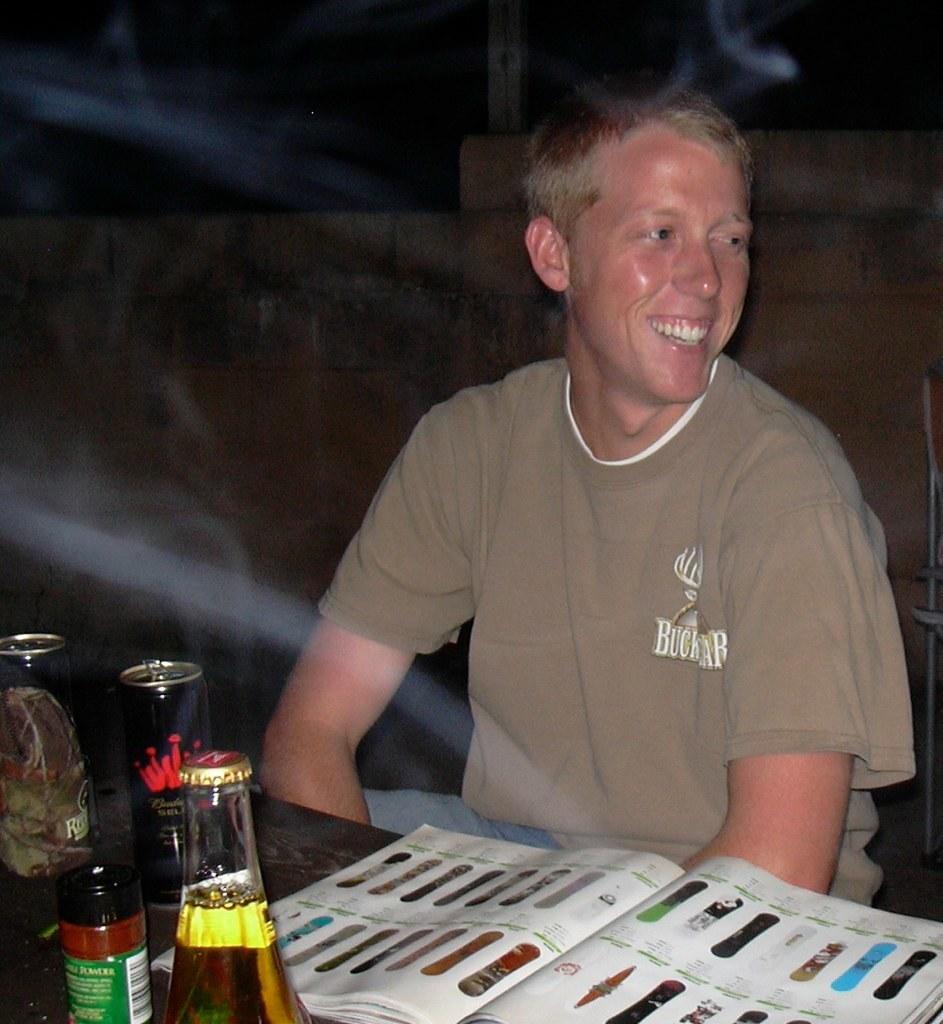Can you describe this image briefly? In this image i can see a person sitting in front of a table wearing brown t shirt. On the table i can see a book, few glasses and few tins. In the background i can see a wall and the dark sky. 